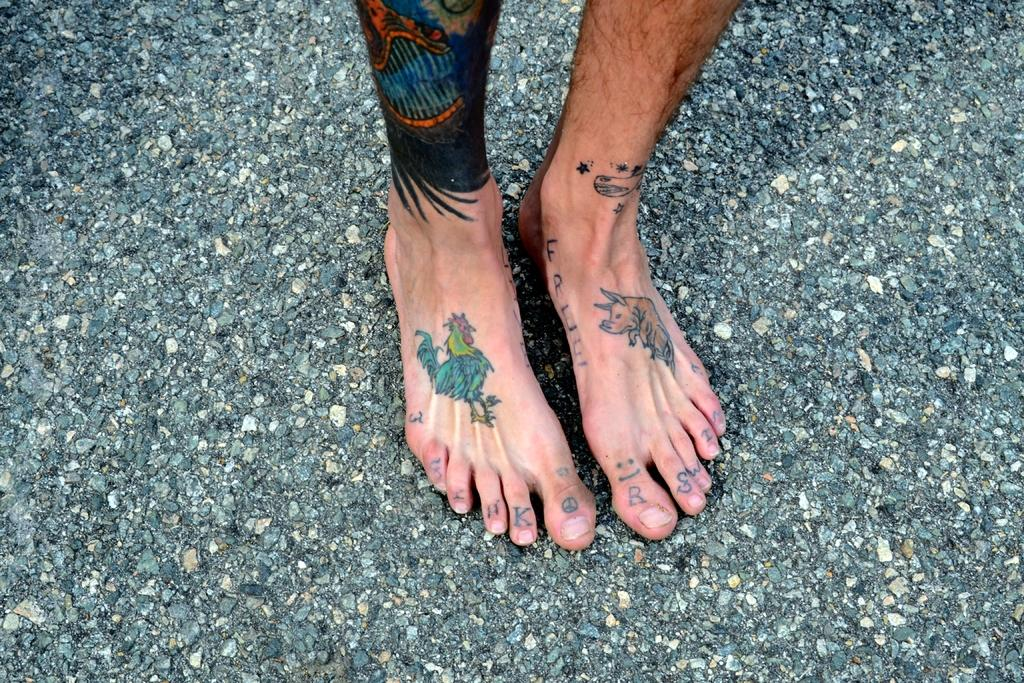What is the main subject of the image? There is a person in the image. Where is the person located? The person is standing on a road. What can be observed about the person's appearance? The person has tattoos on their legs. What month is being celebrated in the image? There is no indication of a specific month being celebrated in the image. How is the person using the tattoos on their legs in the image? The image does not show the person using the tattoos on their legs in any particular way. 